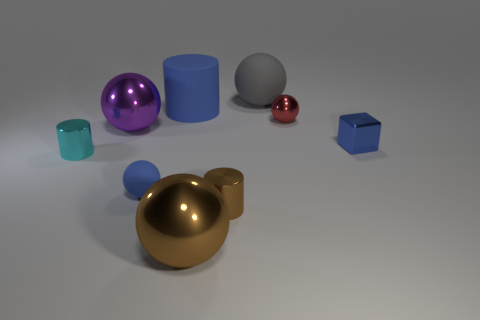Subtract all gray balls. How many balls are left? 4 Subtract all small blue rubber spheres. How many spheres are left? 4 Subtract 1 spheres. How many spheres are left? 4 Subtract all purple balls. Subtract all gray cubes. How many balls are left? 4 Subtract all cylinders. How many objects are left? 6 Add 4 gray rubber objects. How many gray rubber objects are left? 5 Add 3 tiny brown cylinders. How many tiny brown cylinders exist? 4 Subtract 0 gray blocks. How many objects are left? 9 Subtract all small cyan metal objects. Subtract all large yellow balls. How many objects are left? 8 